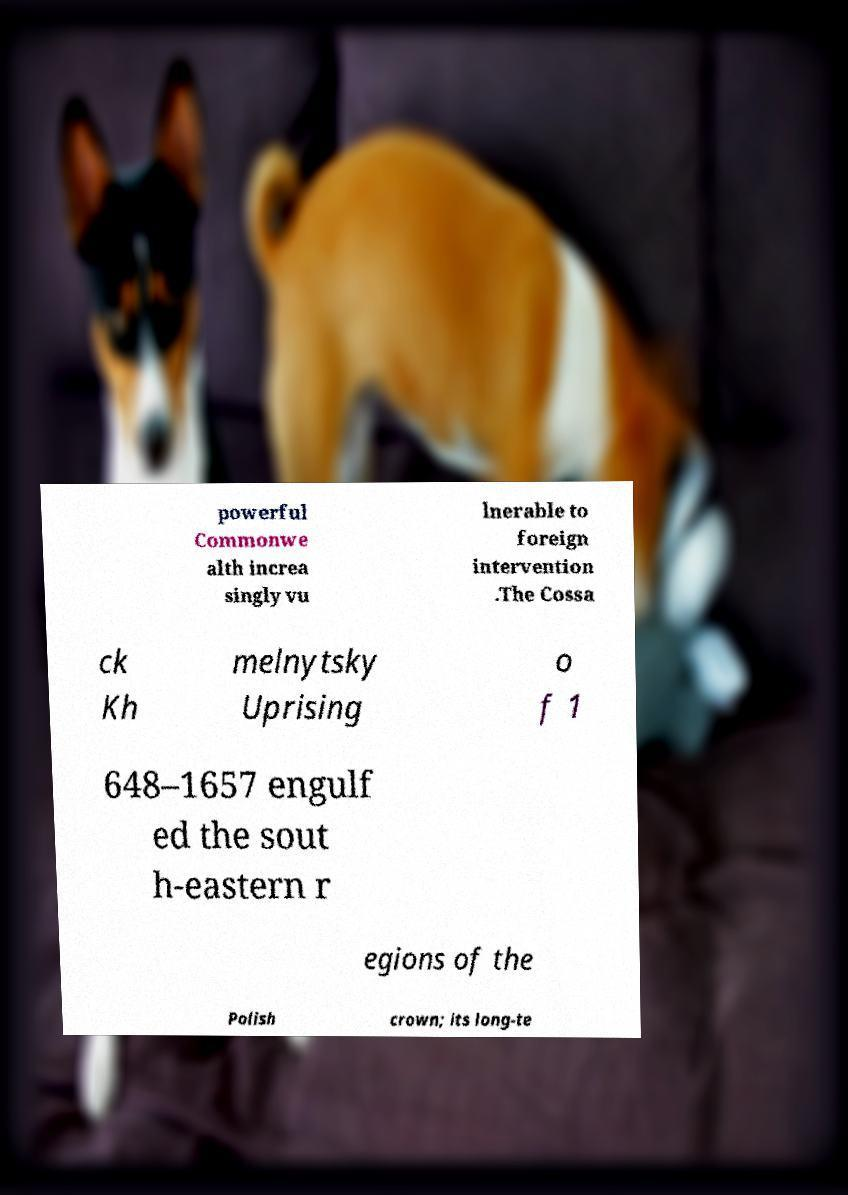Could you assist in decoding the text presented in this image and type it out clearly? powerful Commonwe alth increa singly vu lnerable to foreign intervention .The Cossa ck Kh melnytsky Uprising o f 1 648–1657 engulf ed the sout h-eastern r egions of the Polish crown; its long-te 